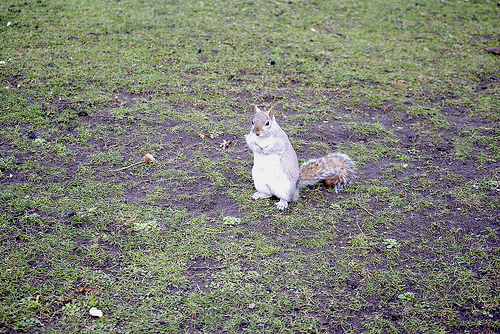<image>
Is there a squirrel on the floor? Yes. Looking at the image, I can see the squirrel is positioned on top of the floor, with the floor providing support. 